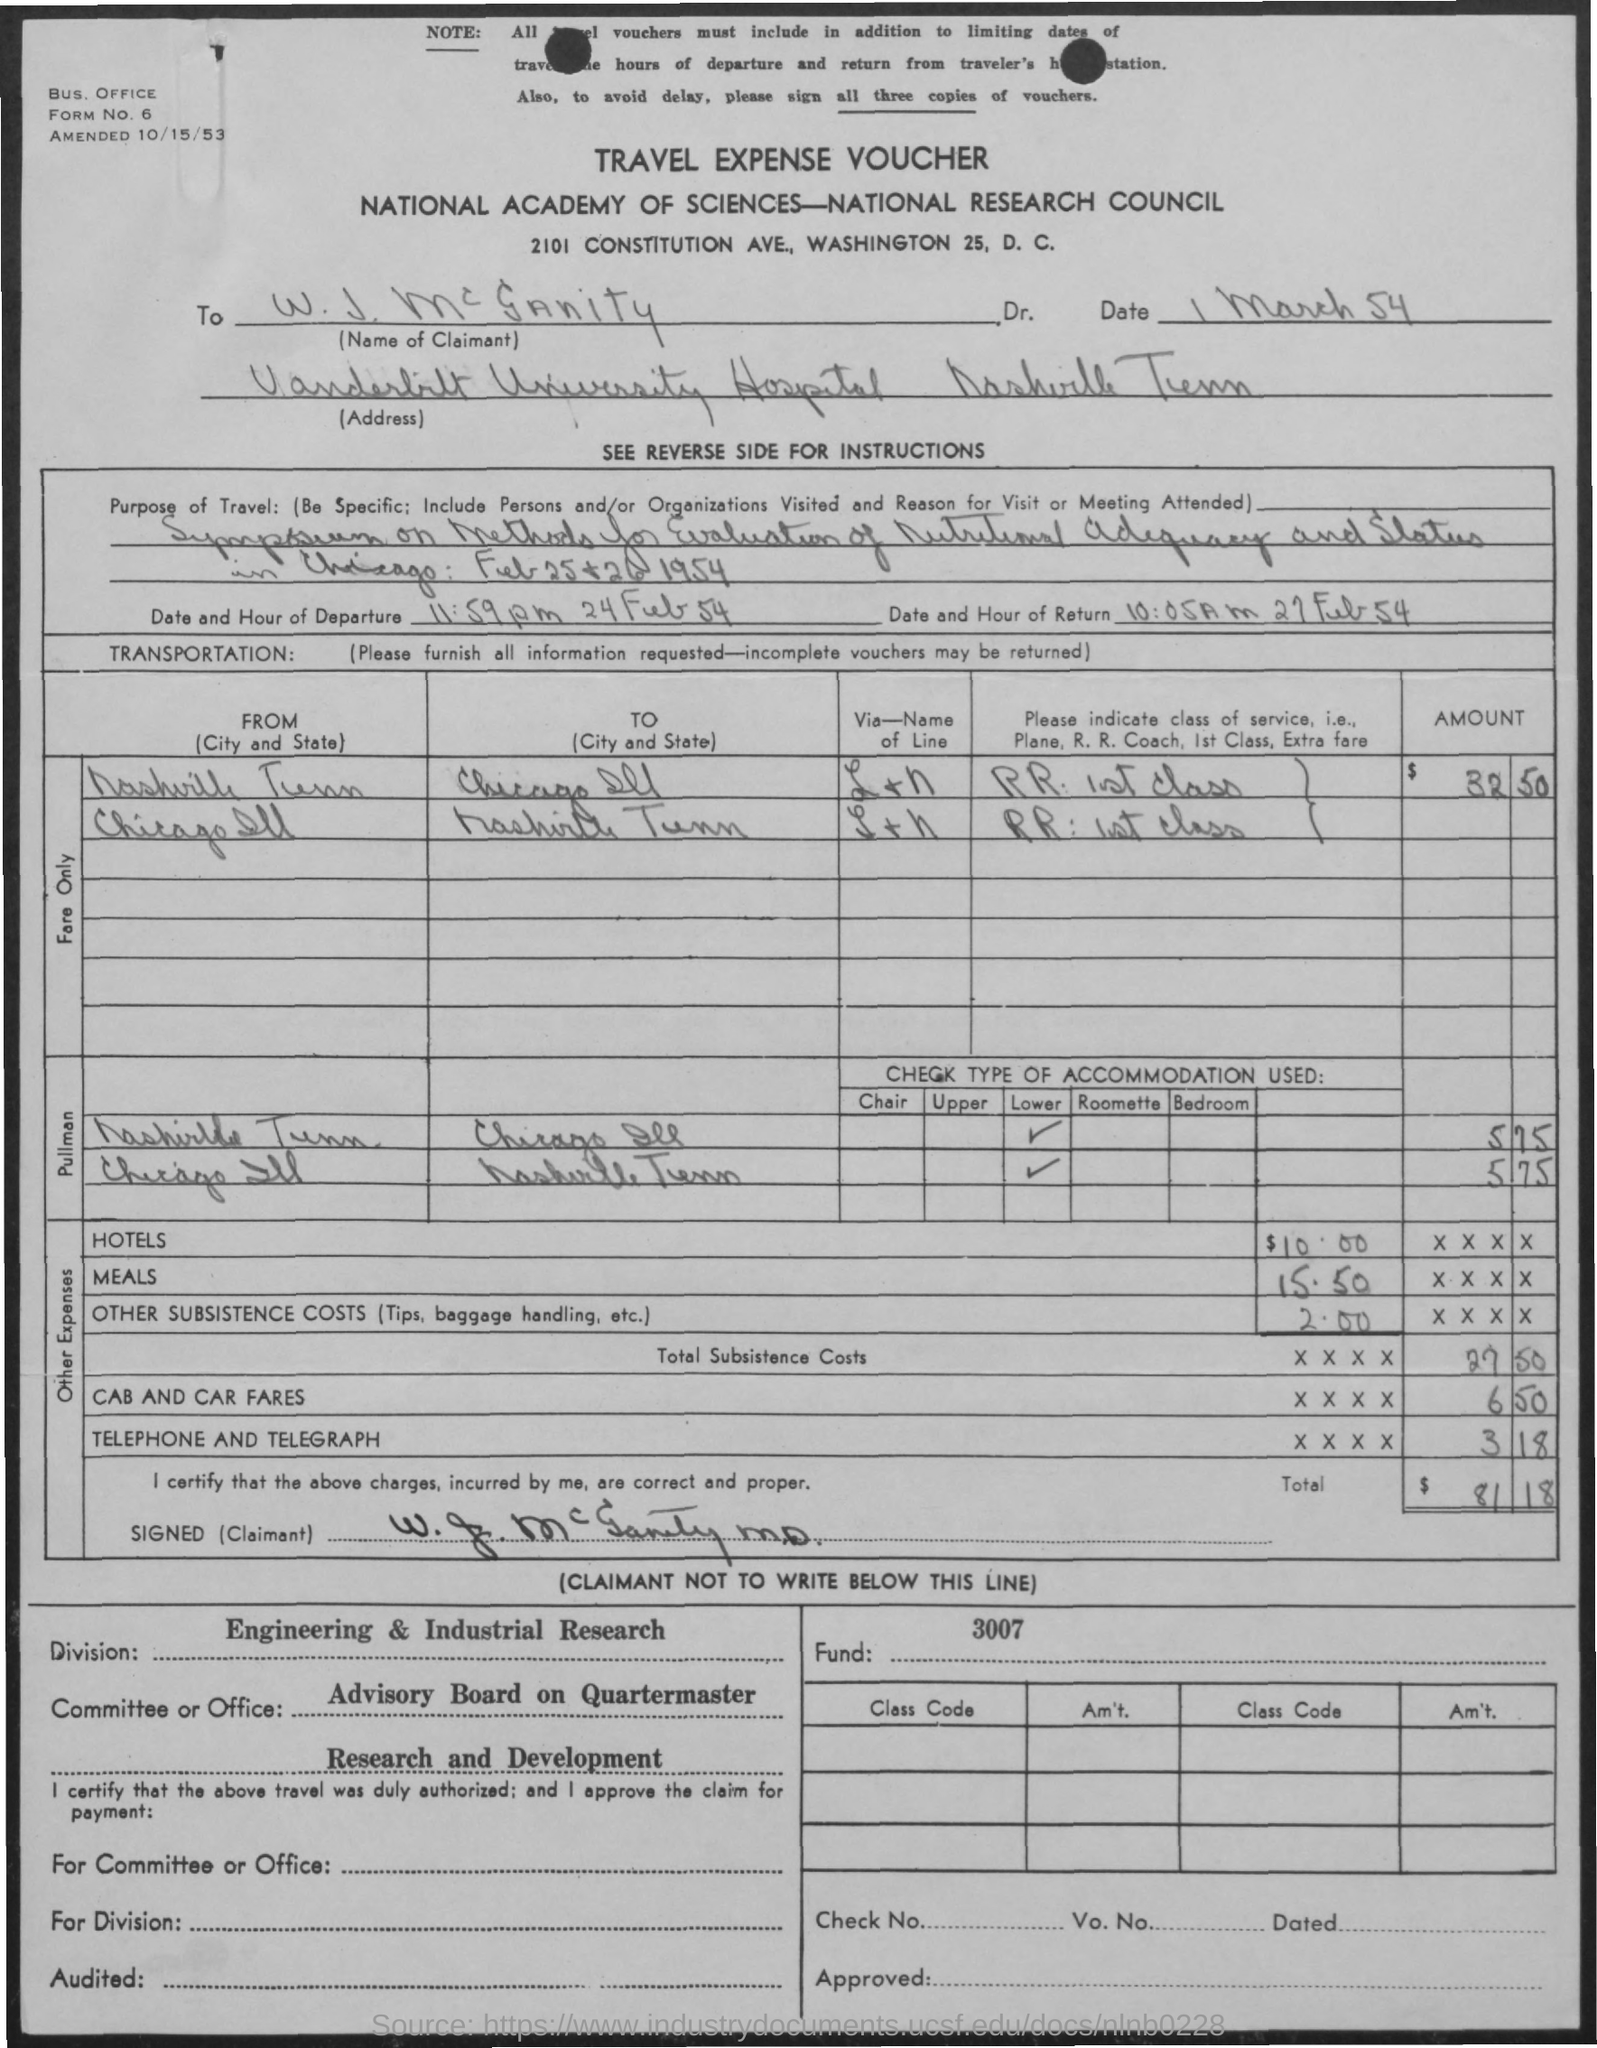What is the form no ?
Your answer should be very brief. 6. What is the date of amendment ?
Your answer should be very brief. 10/15/53. To whom this voucher is sent ?
Offer a very short reply. W. J. McGanity Dr. What is the date and hour of return as mentioned in the given form ?
Ensure brevity in your answer.  10:05 AM 27 Feb 54. What is the date and hour of departure as mentioned in the given page ?
Offer a terse response. 11:59 p.m  24 Feb 54. What is the name of the voucher ?
Ensure brevity in your answer.  Travel Expense Voucher. What is the amount for hotels mentioned in the given voucher ?
Make the answer very short. $10.00. What is the amount mentioned for meals ?
Provide a short and direct response. 15.50. What is the total amount mentioned in the given voucher ?
Keep it short and to the point. $ 81 18. 